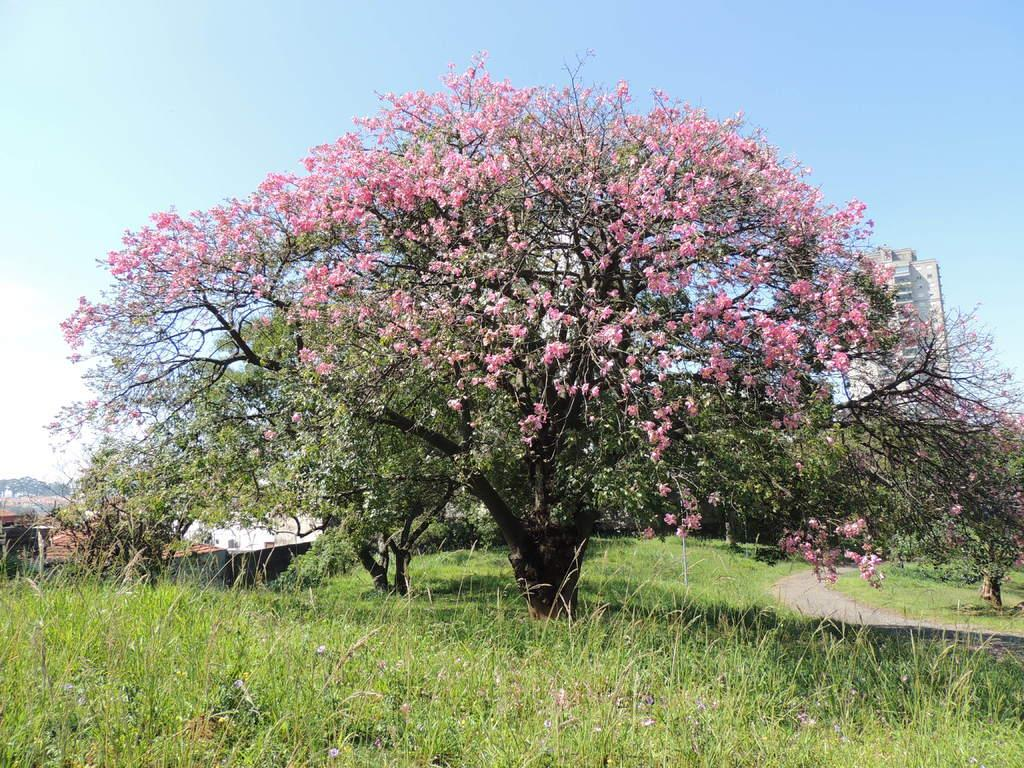What type of tree is present in the image? There is a tree with flowers in the image. What structures can be seen in the image? There are buildings in the image. What is the pathway for vehicles or pedestrians in the image? There is a road in the image. What other types of vegetation are present in the image? There are plants in the image. What can be seen above the ground in the image? The sky is visible in the image. What is present in the sky? There are clouds in the sky. What type of mass is being produced by the tree in the image? There is no mass being produced by the tree in the image; it is simply a tree with flowers. What hope can be seen in the image? The image does not depict any specific hope or emotion; it is a scene with a tree, buildings, a road, plants, sky, and clouds. 